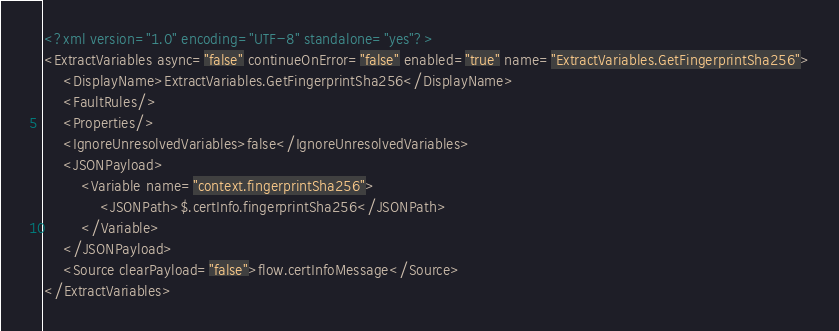<code> <loc_0><loc_0><loc_500><loc_500><_XML_><?xml version="1.0" encoding="UTF-8" standalone="yes"?>
<ExtractVariables async="false" continueOnError="false" enabled="true" name="ExtractVariables.GetFingerprintSha256">
    <DisplayName>ExtractVariables.GetFingerprintSha256</DisplayName>
    <FaultRules/>
    <Properties/>
    <IgnoreUnresolvedVariables>false</IgnoreUnresolvedVariables>
    <JSONPayload>
        <Variable name="context.fingerprintSha256">
            <JSONPath>$.certInfo.fingerprintSha256</JSONPath>
        </Variable>
    </JSONPayload>
    <Source clearPayload="false">flow.certInfoMessage</Source>
</ExtractVariables>
</code> 